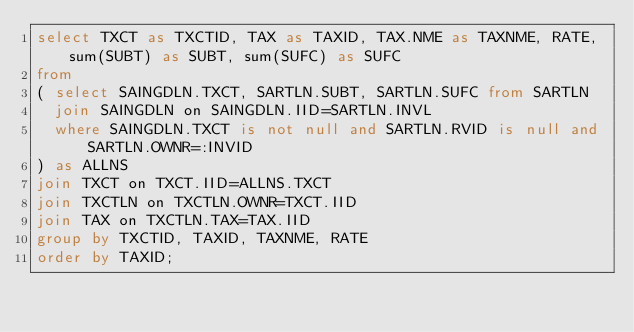<code> <loc_0><loc_0><loc_500><loc_500><_SQL_>select TXCT as TXCTID, TAX as TAXID, TAX.NME as TAXNME, RATE, sum(SUBT) as SUBT, sum(SUFC) as SUFC
from
( select SAINGDLN.TXCT, SARTLN.SUBT, SARTLN.SUFC from SARTLN
  join SAINGDLN on SAINGDLN.IID=SARTLN.INVL
  where SAINGDLN.TXCT is not null and SARTLN.RVID is null and SARTLN.OWNR=:INVID
) as ALLNS
join TXCT on TXCT.IID=ALLNS.TXCT
join TXCTLN on TXCTLN.OWNR=TXCT.IID
join TAX on TXCTLN.TAX=TAX.IID
group by TXCTID, TAXID, TAXNME, RATE
order by TAXID;
</code> 